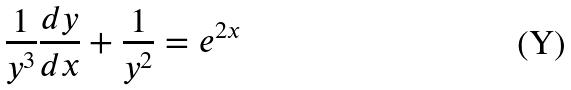<formula> <loc_0><loc_0><loc_500><loc_500>\frac { 1 } { y ^ { 3 } } \frac { d y } { d x } + \frac { 1 } { y ^ { 2 } } = e ^ { 2 x }</formula> 